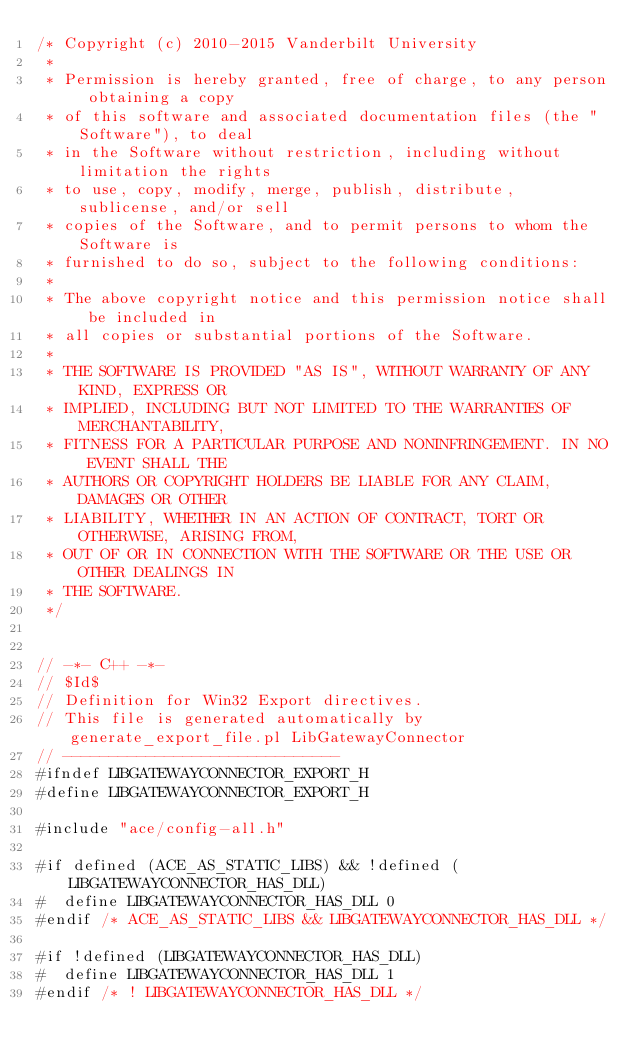<code> <loc_0><loc_0><loc_500><loc_500><_C_>/* Copyright (c) 2010-2015 Vanderbilt University
 * 
 * Permission is hereby granted, free of charge, to any person obtaining a copy
 * of this software and associated documentation files (the "Software"), to deal
 * in the Software without restriction, including without limitation the rights
 * to use, copy, modify, merge, publish, distribute, sublicense, and/or sell
 * copies of the Software, and to permit persons to whom the Software is
 * furnished to do so, subject to the following conditions:
 * 
 * The above copyright notice and this permission notice shall be included in
 * all copies or substantial portions of the Software.
 * 
 * THE SOFTWARE IS PROVIDED "AS IS", WITHOUT WARRANTY OF ANY KIND, EXPRESS OR
 * IMPLIED, INCLUDING BUT NOT LIMITED TO THE WARRANTIES OF MERCHANTABILITY,
 * FITNESS FOR A PARTICULAR PURPOSE AND NONINFRINGEMENT. IN NO EVENT SHALL THE
 * AUTHORS OR COPYRIGHT HOLDERS BE LIABLE FOR ANY CLAIM, DAMAGES OR OTHER
 * LIABILITY, WHETHER IN AN ACTION OF CONTRACT, TORT OR OTHERWISE, ARISING FROM,
 * OUT OF OR IN CONNECTION WITH THE SOFTWARE OR THE USE OR OTHER DEALINGS IN
 * THE SOFTWARE.
 */


// -*- C++ -*-
// $Id$
// Definition for Win32 Export directives.
// This file is generated automatically by generate_export_file.pl LibGatewayConnector
// ------------------------------
#ifndef LIBGATEWAYCONNECTOR_EXPORT_H
#define LIBGATEWAYCONNECTOR_EXPORT_H

#include "ace/config-all.h"

#if defined (ACE_AS_STATIC_LIBS) && !defined (LIBGATEWAYCONNECTOR_HAS_DLL)
#  define LIBGATEWAYCONNECTOR_HAS_DLL 0
#endif /* ACE_AS_STATIC_LIBS && LIBGATEWAYCONNECTOR_HAS_DLL */

#if !defined (LIBGATEWAYCONNECTOR_HAS_DLL)
#  define LIBGATEWAYCONNECTOR_HAS_DLL 1
#endif /* ! LIBGATEWAYCONNECTOR_HAS_DLL */
</code> 